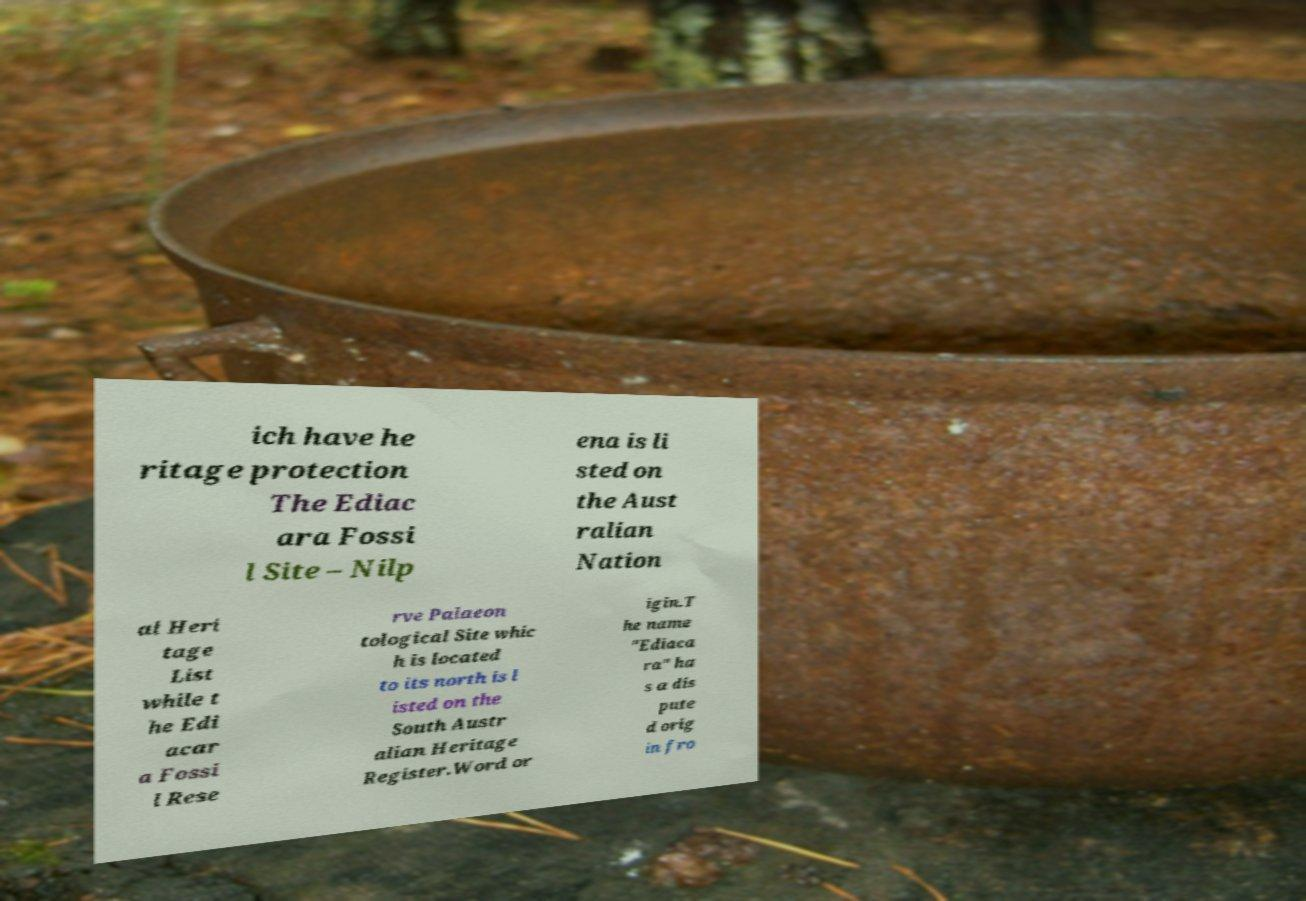Please read and relay the text visible in this image. What does it say? ich have he ritage protection The Ediac ara Fossi l Site – Nilp ena is li sted on the Aust ralian Nation al Heri tage List while t he Edi acar a Fossi l Rese rve Palaeon tological Site whic h is located to its north is l isted on the South Austr alian Heritage Register.Word or igin.T he name "Ediaca ra" ha s a dis pute d orig in fro 